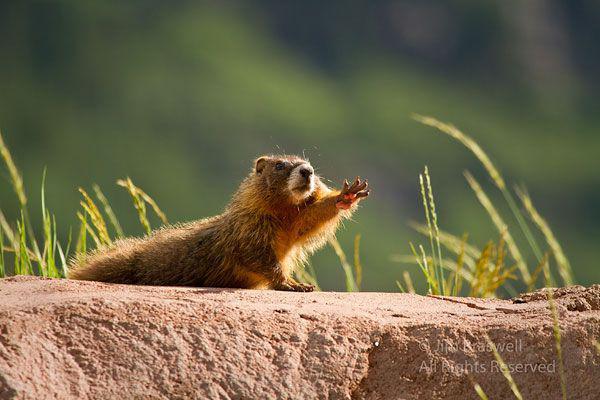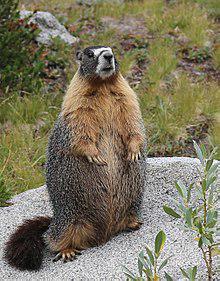The first image is the image on the left, the second image is the image on the right. For the images shown, is this caption "An image shows an upright rodent-type animal." true? Answer yes or no. Yes. 